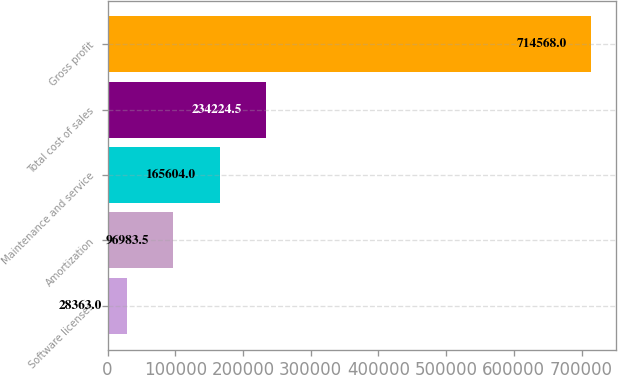<chart> <loc_0><loc_0><loc_500><loc_500><bar_chart><fcel>Software licenses<fcel>Amortization<fcel>Maintenance and service<fcel>Total cost of sales<fcel>Gross profit<nl><fcel>28363<fcel>96983.5<fcel>165604<fcel>234224<fcel>714568<nl></chart> 